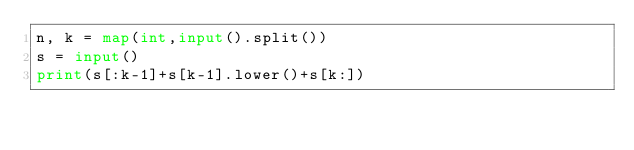<code> <loc_0><loc_0><loc_500><loc_500><_Python_>n, k = map(int,input().split())
s = input()
print(s[:k-1]+s[k-1].lower()+s[k:])</code> 